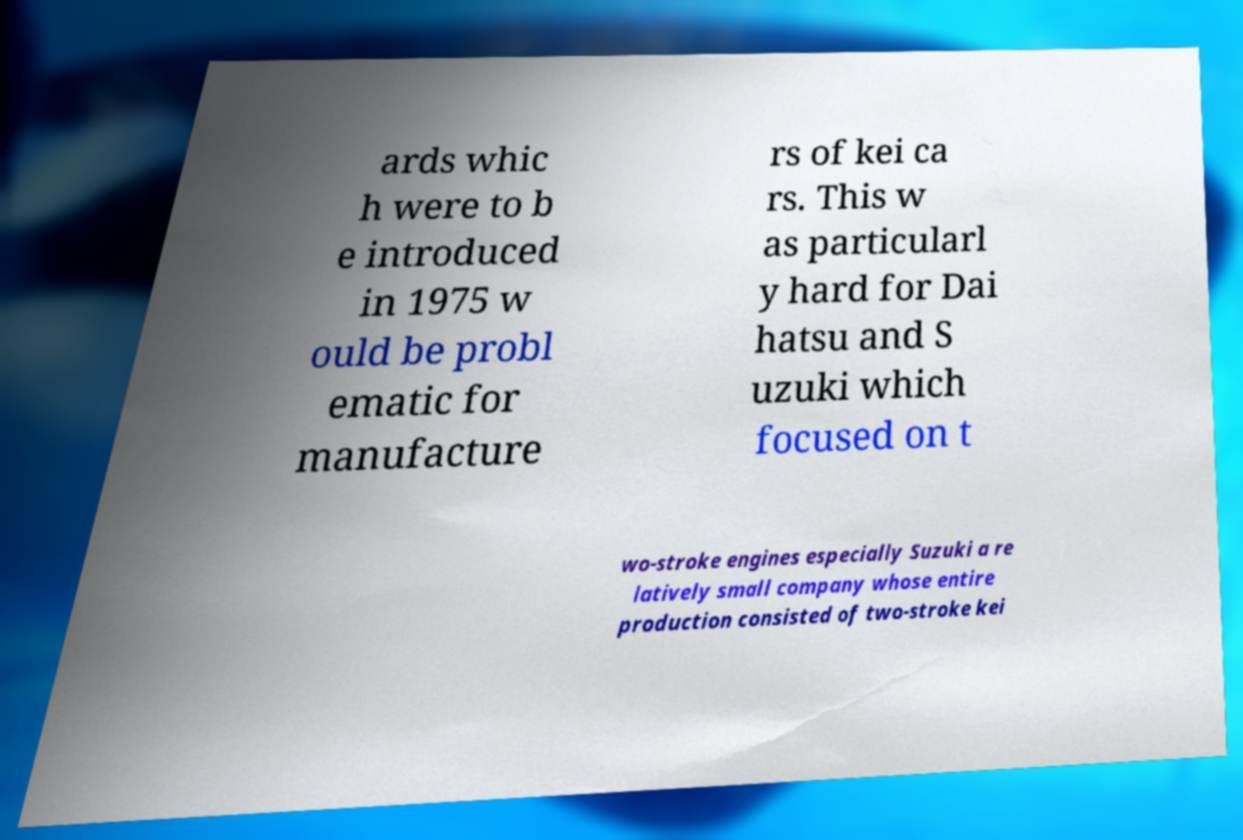There's text embedded in this image that I need extracted. Can you transcribe it verbatim? ards whic h were to b e introduced in 1975 w ould be probl ematic for manufacture rs of kei ca rs. This w as particularl y hard for Dai hatsu and S uzuki which focused on t wo-stroke engines especially Suzuki a re latively small company whose entire production consisted of two-stroke kei 